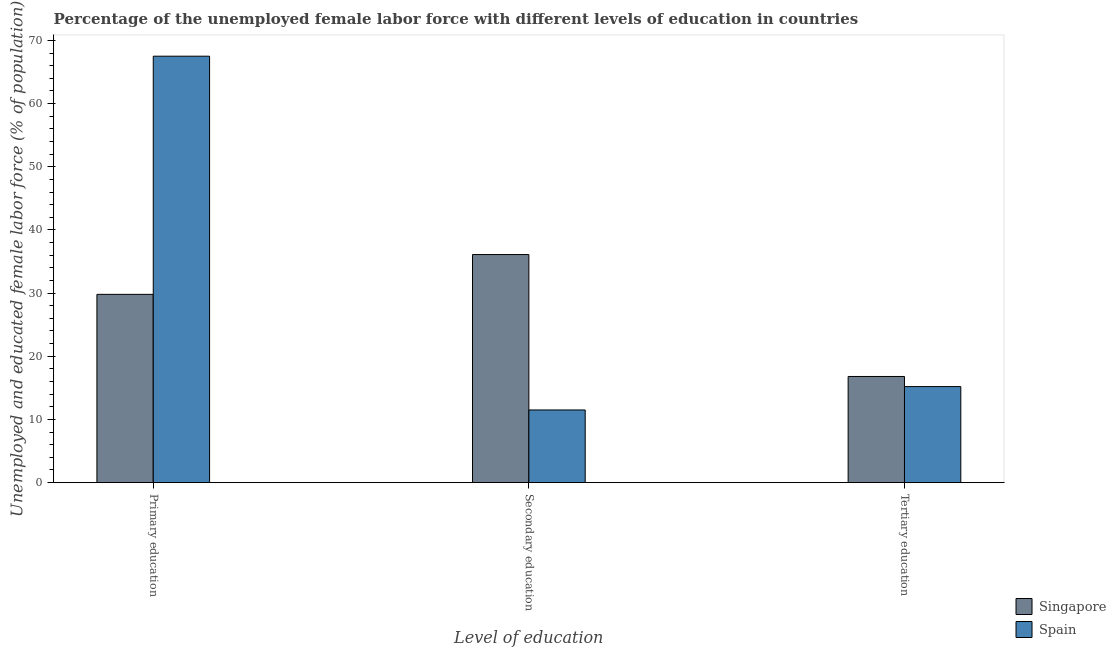How many different coloured bars are there?
Provide a succinct answer. 2. How many groups of bars are there?
Your response must be concise. 3. Are the number of bars per tick equal to the number of legend labels?
Provide a succinct answer. Yes. What is the label of the 3rd group of bars from the left?
Offer a terse response. Tertiary education. What is the percentage of female labor force who received tertiary education in Singapore?
Make the answer very short. 16.8. Across all countries, what is the maximum percentage of female labor force who received secondary education?
Ensure brevity in your answer.  36.1. Across all countries, what is the minimum percentage of female labor force who received tertiary education?
Give a very brief answer. 15.2. In which country was the percentage of female labor force who received tertiary education maximum?
Make the answer very short. Singapore. In which country was the percentage of female labor force who received primary education minimum?
Offer a terse response. Singapore. What is the total percentage of female labor force who received tertiary education in the graph?
Your answer should be very brief. 32. What is the difference between the percentage of female labor force who received secondary education in Singapore and that in Spain?
Provide a short and direct response. 24.6. What is the difference between the percentage of female labor force who received secondary education in Singapore and the percentage of female labor force who received primary education in Spain?
Give a very brief answer. -31.4. What is the average percentage of female labor force who received secondary education per country?
Provide a short and direct response. 23.8. What is the ratio of the percentage of female labor force who received primary education in Spain to that in Singapore?
Offer a very short reply. 2.27. Is the percentage of female labor force who received secondary education in Spain less than that in Singapore?
Provide a succinct answer. Yes. What is the difference between the highest and the second highest percentage of female labor force who received tertiary education?
Ensure brevity in your answer.  1.6. What is the difference between the highest and the lowest percentage of female labor force who received tertiary education?
Your answer should be compact. 1.6. What does the 2nd bar from the right in Primary education represents?
Provide a short and direct response. Singapore. How many bars are there?
Provide a short and direct response. 6. Are all the bars in the graph horizontal?
Provide a short and direct response. No. How many countries are there in the graph?
Your answer should be very brief. 2. What is the difference between two consecutive major ticks on the Y-axis?
Offer a very short reply. 10. Are the values on the major ticks of Y-axis written in scientific E-notation?
Provide a short and direct response. No. Does the graph contain grids?
Give a very brief answer. No. Where does the legend appear in the graph?
Ensure brevity in your answer.  Bottom right. What is the title of the graph?
Your response must be concise. Percentage of the unemployed female labor force with different levels of education in countries. Does "Kosovo" appear as one of the legend labels in the graph?
Provide a succinct answer. No. What is the label or title of the X-axis?
Make the answer very short. Level of education. What is the label or title of the Y-axis?
Offer a terse response. Unemployed and educated female labor force (% of population). What is the Unemployed and educated female labor force (% of population) of Singapore in Primary education?
Keep it short and to the point. 29.8. What is the Unemployed and educated female labor force (% of population) in Spain in Primary education?
Your answer should be very brief. 67.5. What is the Unemployed and educated female labor force (% of population) in Singapore in Secondary education?
Ensure brevity in your answer.  36.1. What is the Unemployed and educated female labor force (% of population) in Singapore in Tertiary education?
Your response must be concise. 16.8. What is the Unemployed and educated female labor force (% of population) in Spain in Tertiary education?
Provide a short and direct response. 15.2. Across all Level of education, what is the maximum Unemployed and educated female labor force (% of population) in Singapore?
Your answer should be compact. 36.1. Across all Level of education, what is the maximum Unemployed and educated female labor force (% of population) in Spain?
Make the answer very short. 67.5. Across all Level of education, what is the minimum Unemployed and educated female labor force (% of population) of Singapore?
Offer a very short reply. 16.8. What is the total Unemployed and educated female labor force (% of population) in Singapore in the graph?
Offer a terse response. 82.7. What is the total Unemployed and educated female labor force (% of population) in Spain in the graph?
Your response must be concise. 94.2. What is the difference between the Unemployed and educated female labor force (% of population) of Singapore in Primary education and that in Secondary education?
Make the answer very short. -6.3. What is the difference between the Unemployed and educated female labor force (% of population) of Spain in Primary education and that in Secondary education?
Your response must be concise. 56. What is the difference between the Unemployed and educated female labor force (% of population) of Spain in Primary education and that in Tertiary education?
Your response must be concise. 52.3. What is the difference between the Unemployed and educated female labor force (% of population) in Singapore in Secondary education and that in Tertiary education?
Your response must be concise. 19.3. What is the difference between the Unemployed and educated female labor force (% of population) in Spain in Secondary education and that in Tertiary education?
Offer a very short reply. -3.7. What is the difference between the Unemployed and educated female labor force (% of population) of Singapore in Primary education and the Unemployed and educated female labor force (% of population) of Spain in Secondary education?
Offer a terse response. 18.3. What is the difference between the Unemployed and educated female labor force (% of population) of Singapore in Primary education and the Unemployed and educated female labor force (% of population) of Spain in Tertiary education?
Your response must be concise. 14.6. What is the difference between the Unemployed and educated female labor force (% of population) in Singapore in Secondary education and the Unemployed and educated female labor force (% of population) in Spain in Tertiary education?
Make the answer very short. 20.9. What is the average Unemployed and educated female labor force (% of population) of Singapore per Level of education?
Ensure brevity in your answer.  27.57. What is the average Unemployed and educated female labor force (% of population) in Spain per Level of education?
Make the answer very short. 31.4. What is the difference between the Unemployed and educated female labor force (% of population) of Singapore and Unemployed and educated female labor force (% of population) of Spain in Primary education?
Provide a short and direct response. -37.7. What is the difference between the Unemployed and educated female labor force (% of population) in Singapore and Unemployed and educated female labor force (% of population) in Spain in Secondary education?
Make the answer very short. 24.6. What is the difference between the Unemployed and educated female labor force (% of population) in Singapore and Unemployed and educated female labor force (% of population) in Spain in Tertiary education?
Give a very brief answer. 1.6. What is the ratio of the Unemployed and educated female labor force (% of population) of Singapore in Primary education to that in Secondary education?
Keep it short and to the point. 0.83. What is the ratio of the Unemployed and educated female labor force (% of population) in Spain in Primary education to that in Secondary education?
Ensure brevity in your answer.  5.87. What is the ratio of the Unemployed and educated female labor force (% of population) in Singapore in Primary education to that in Tertiary education?
Give a very brief answer. 1.77. What is the ratio of the Unemployed and educated female labor force (% of population) in Spain in Primary education to that in Tertiary education?
Keep it short and to the point. 4.44. What is the ratio of the Unemployed and educated female labor force (% of population) in Singapore in Secondary education to that in Tertiary education?
Make the answer very short. 2.15. What is the ratio of the Unemployed and educated female labor force (% of population) of Spain in Secondary education to that in Tertiary education?
Your answer should be compact. 0.76. What is the difference between the highest and the second highest Unemployed and educated female labor force (% of population) in Spain?
Give a very brief answer. 52.3. What is the difference between the highest and the lowest Unemployed and educated female labor force (% of population) of Singapore?
Ensure brevity in your answer.  19.3. What is the difference between the highest and the lowest Unemployed and educated female labor force (% of population) in Spain?
Your answer should be very brief. 56. 